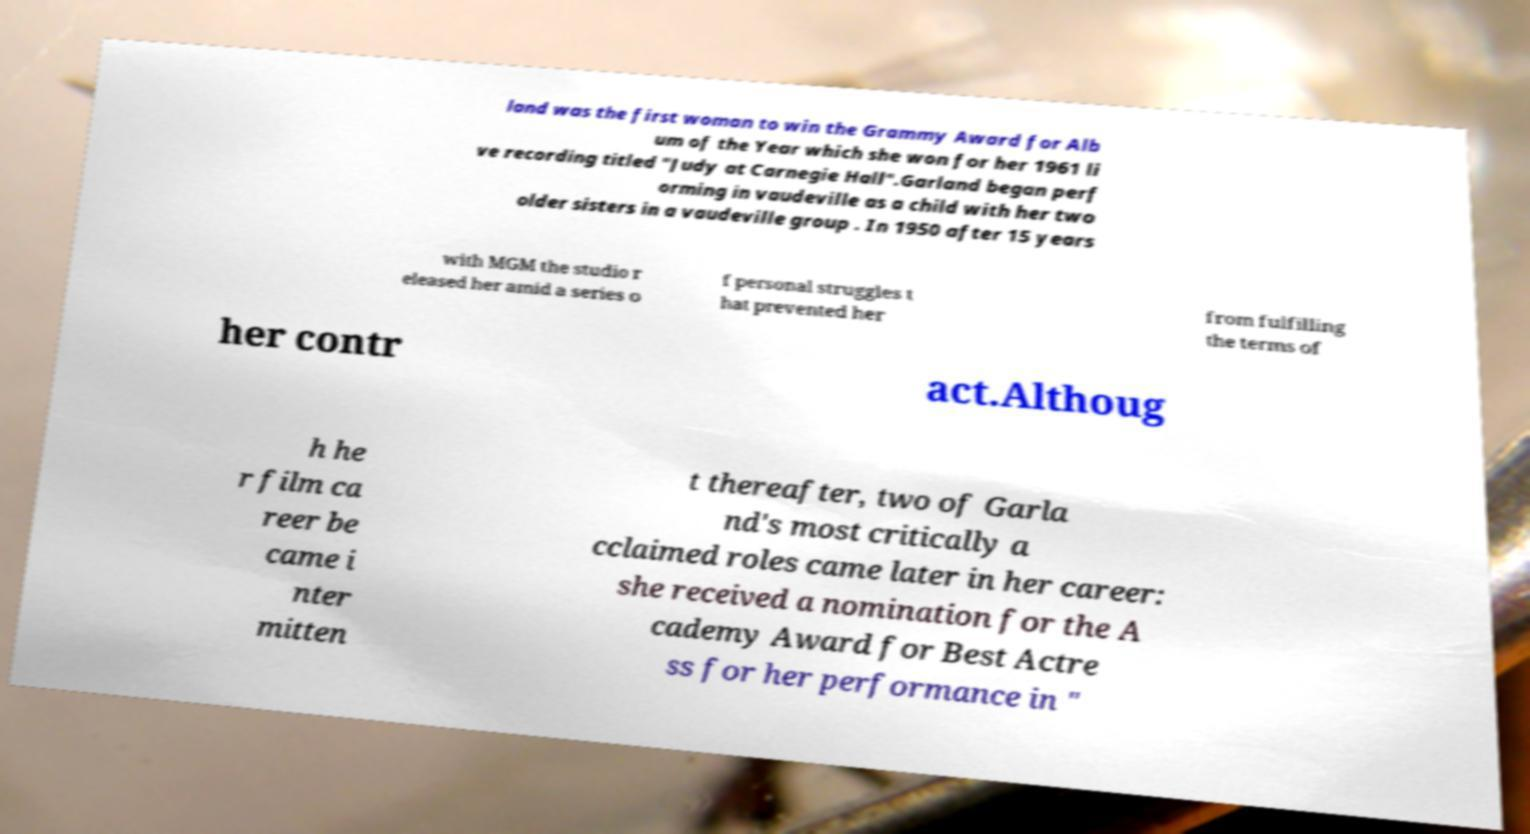Please identify and transcribe the text found in this image. land was the first woman to win the Grammy Award for Alb um of the Year which she won for her 1961 li ve recording titled "Judy at Carnegie Hall".Garland began perf orming in vaudeville as a child with her two older sisters in a vaudeville group . In 1950 after 15 years with MGM the studio r eleased her amid a series o f personal struggles t hat prevented her from fulfilling the terms of her contr act.Althoug h he r film ca reer be came i nter mitten t thereafter, two of Garla nd's most critically a cclaimed roles came later in her career: she received a nomination for the A cademy Award for Best Actre ss for her performance in " 